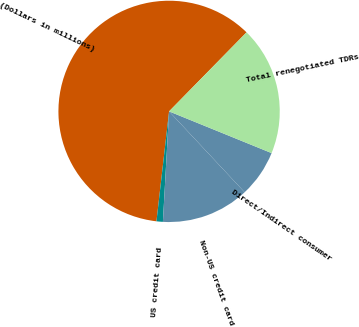Convert chart to OTSL. <chart><loc_0><loc_0><loc_500><loc_500><pie_chart><fcel>(Dollars in millions)<fcel>US credit card<fcel>Non-US credit card<fcel>Direct/Indirect consumer<fcel>Total renegotiated TDRs<nl><fcel>60.52%<fcel>0.93%<fcel>12.85%<fcel>6.89%<fcel>18.81%<nl></chart> 